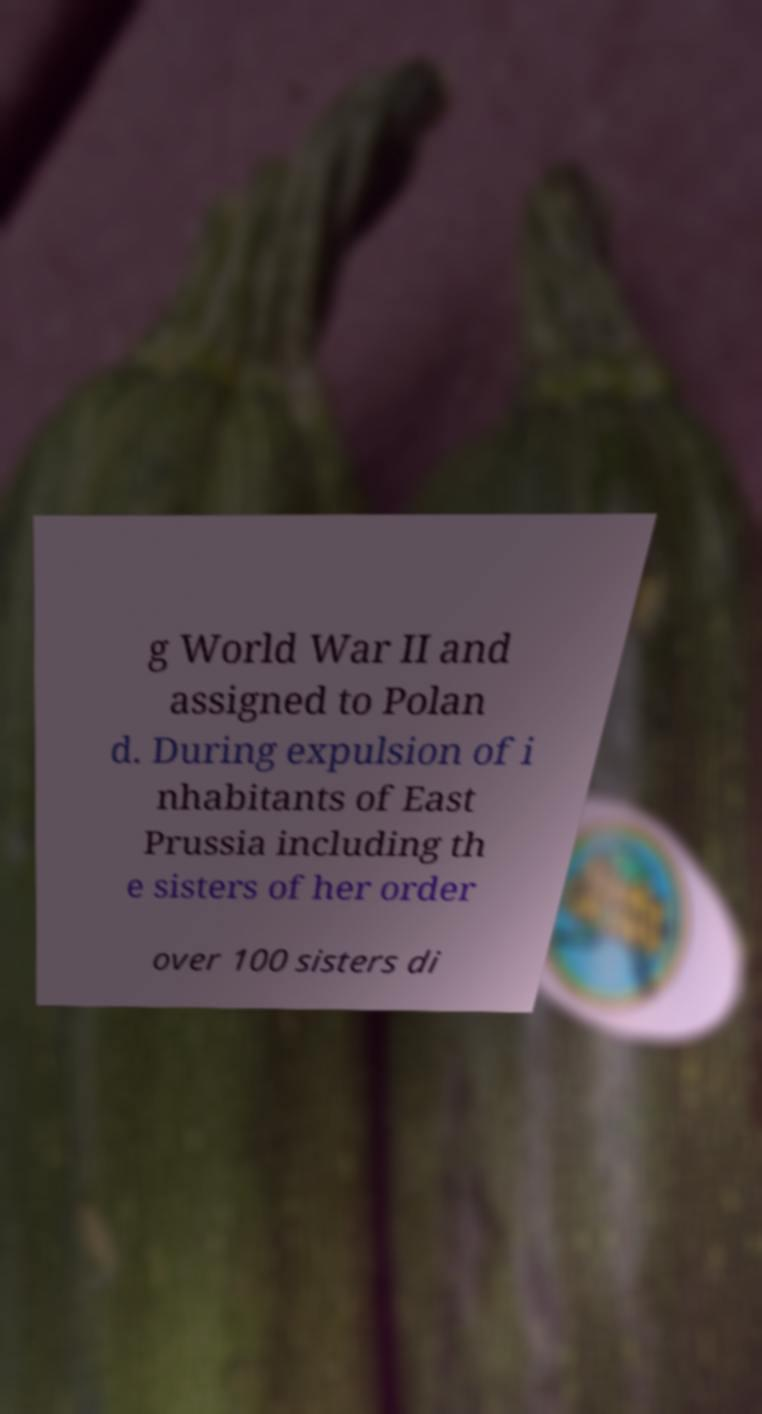Could you assist in decoding the text presented in this image and type it out clearly? g World War II and assigned to Polan d. During expulsion of i nhabitants of East Prussia including th e sisters of her order over 100 sisters di 